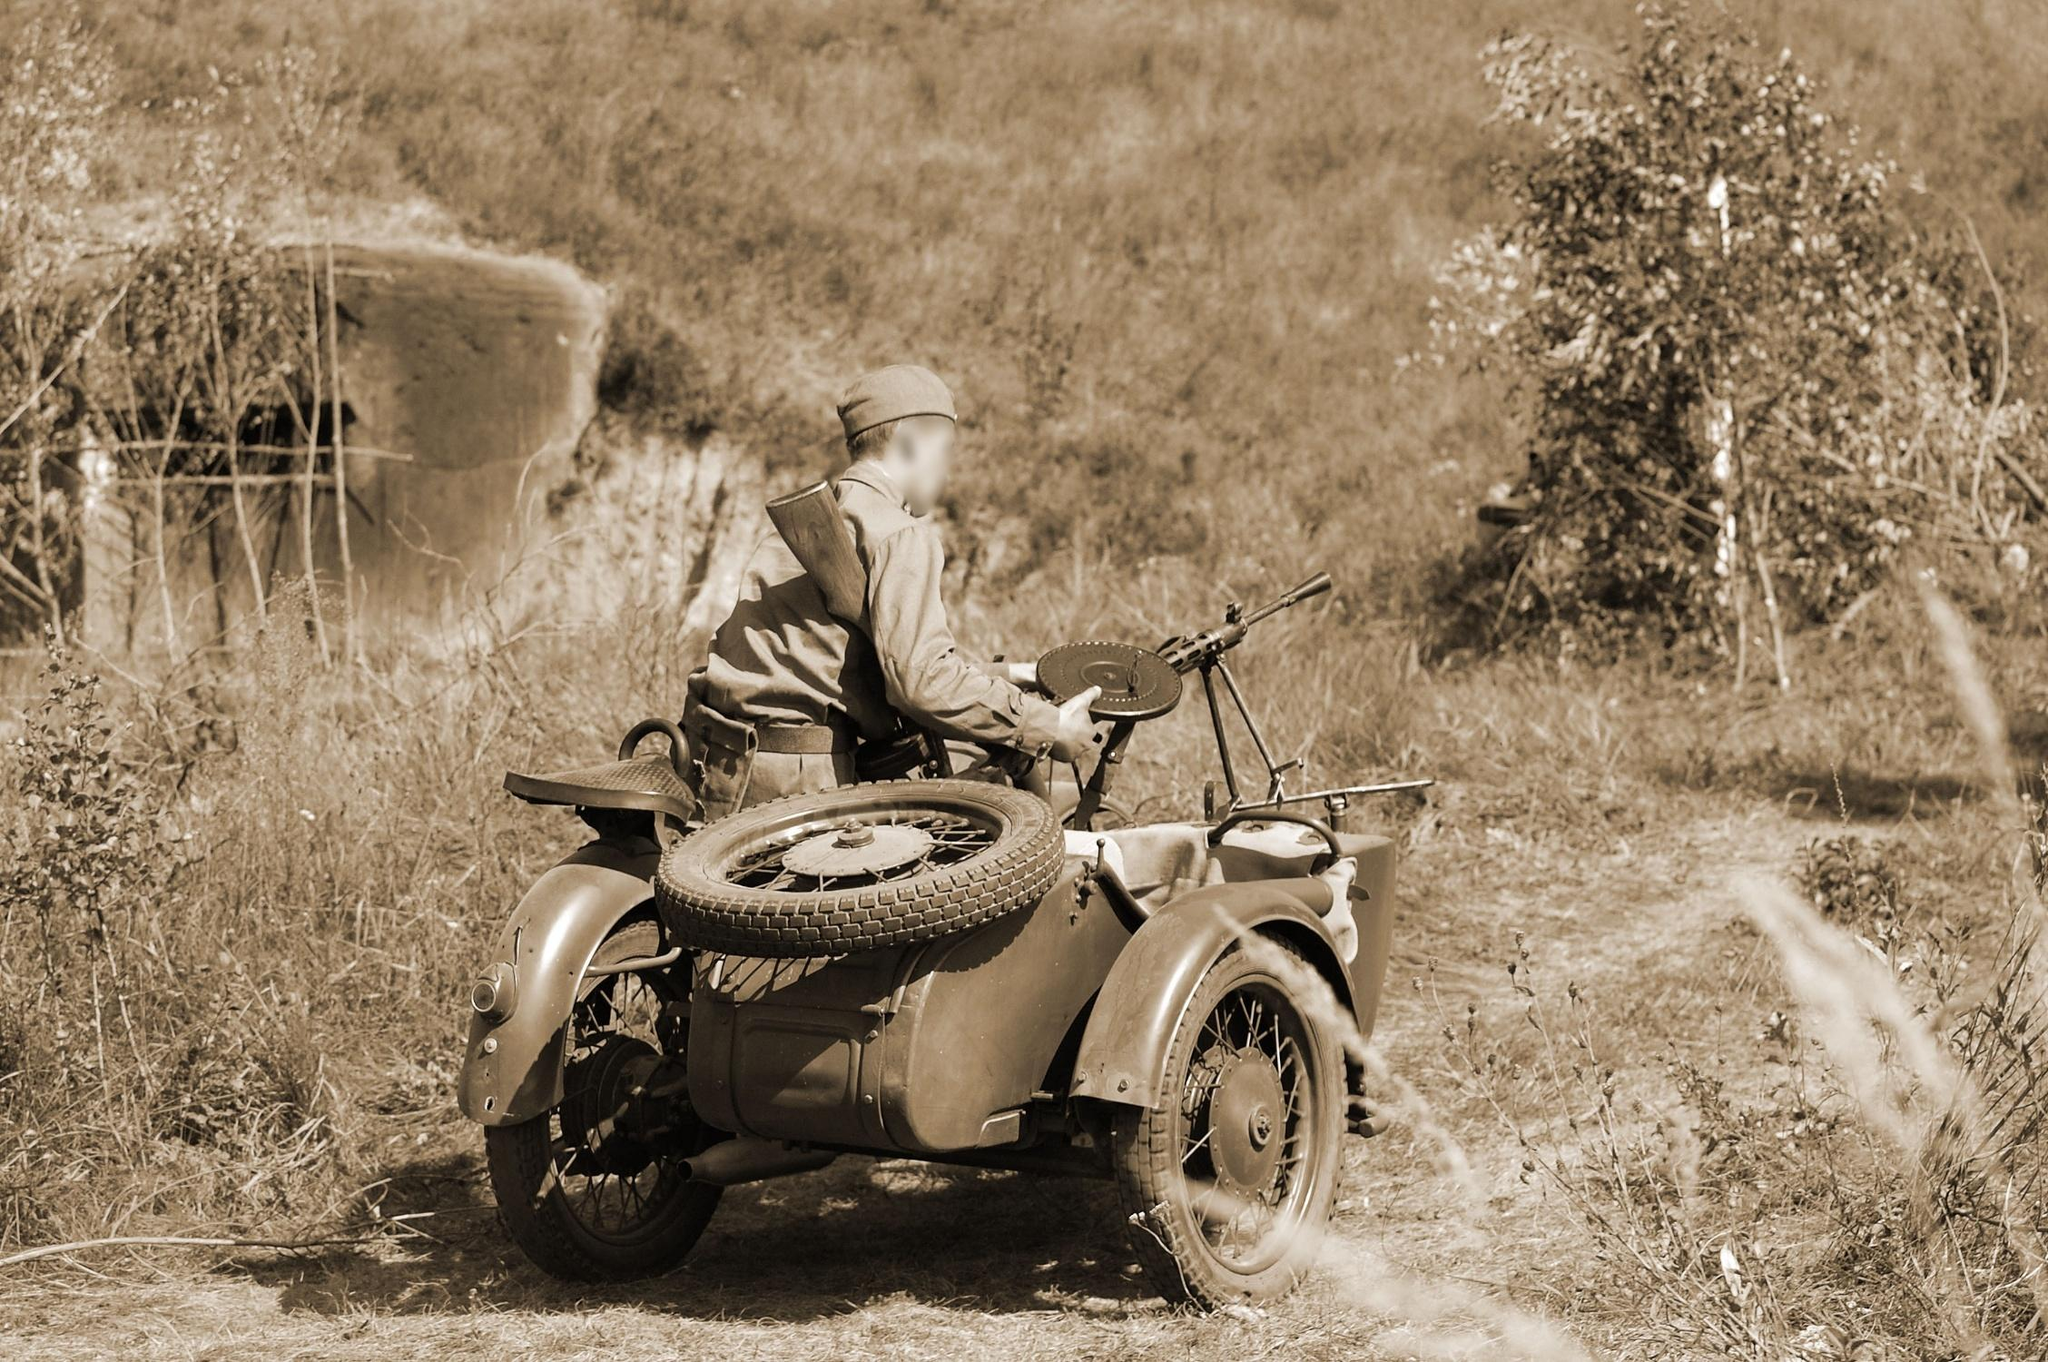What might the rider be thinking about in this tranquil environment? Gazing into the distance, the rider might be immersed in thoughts about the purpose of his journey or reflecting on his surroundings. The tranquil and isolated setting could evoke a sense of solitude, prompting thoughts about personal missions or the complexities of navigating through less traveled paths. What kind of preparations would be necessary for such a journey? For a journey on rugged terrain like this, thorough preparations would include ensuring the motorcycle and sidecar are in optimal condition, packing necessary supplies such as water, food, perhaps maps, and tools for vehicle repair. Additionally, considering the historical context, the rider would also carry essential military items like communication devices or weapons. 